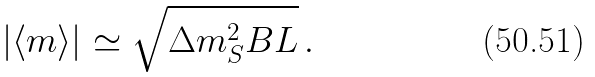<formula> <loc_0><loc_0><loc_500><loc_500>| \langle m \rangle | \simeq \sqrt { \Delta m ^ { 2 } _ { S } B L } \, .</formula> 